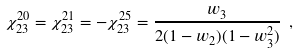Convert formula to latex. <formula><loc_0><loc_0><loc_500><loc_500>\chi _ { 2 3 } ^ { 2 0 } = \chi _ { 2 3 } ^ { 2 1 } = - \chi _ { 2 3 } ^ { 2 5 } = \frac { w _ { 3 } } { 2 ( 1 - w _ { 2 } ) ( 1 - w _ { 3 } ^ { 2 } ) } \ ,</formula> 